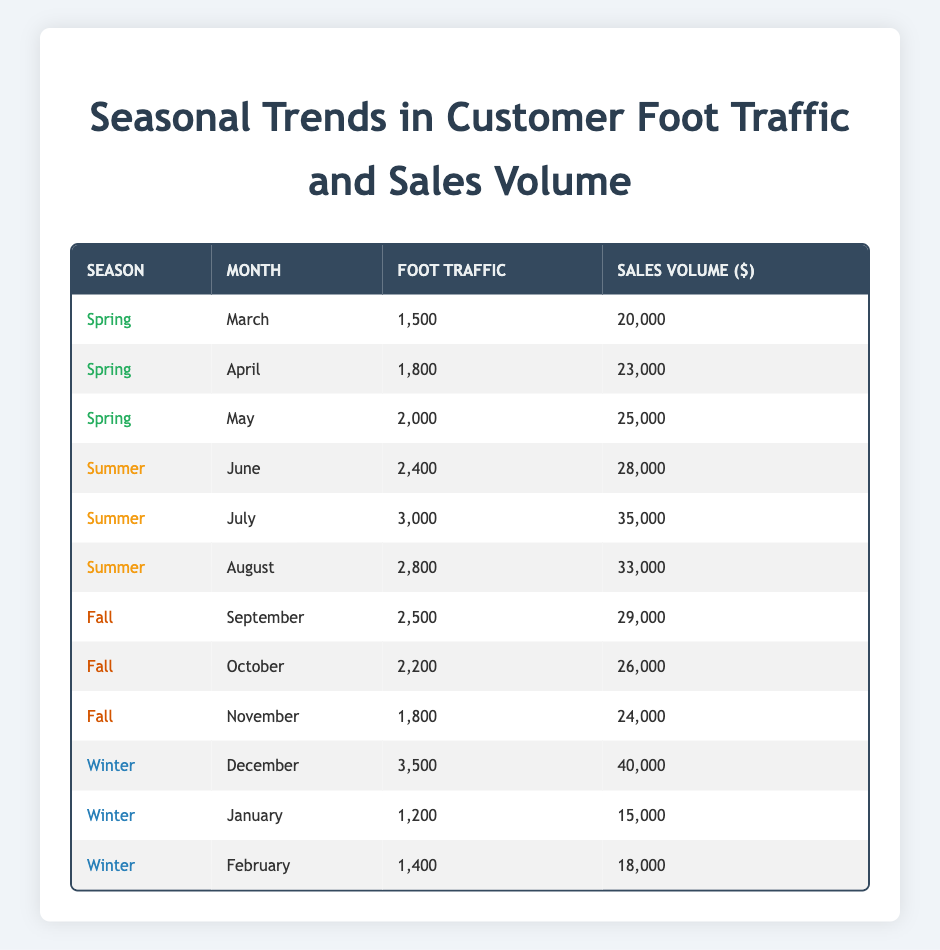What is the foot traffic in July? The table indicates that for the month of July in the summer season, the foot traffic is recorded as 3000.
Answer: 3000 What was the sales volume in December? From the table, it shows that in December during winter, the sales volume is 40000.
Answer: 40000 Which month had the highest foot traffic? To determine this, we compare the foot traffic values across all months. December has the highest foot traffic at 3500.
Answer: December What is the average sales volume for the fall season? The sales volumes for fall months (September: 29000, October: 26000, November: 24000) are summed as (29000 + 26000 + 24000 = 79000) and then divided by 3 months to find the average: 79000/3 = 26333.33.
Answer: 26333.33 Is the foot traffic in October less than in November? The foot traffic for October is 2200, while for November it is 1800. Since 2200 is greater than 1800, the statement is false.
Answer: No What season had the highest average foot traffic? First, we will calculate the average foot traffic for each season. Spring = (1500 + 1800 + 2000)/3 = 1766.67, Summer = (2400 + 3000 + 2800)/3 = 2733.33, Fall = (2500 + 2200 + 1800)/3 = 2166.67, Winter = (3500 + 1200 + 1400)/3 = 2033.33. The highest average is in Summer at 2733.33.
Answer: Summer In which month did sales exceed 30000? We check each sales volume listed in the table: July (35000), August (33000), and December (40000) are the months where sales exceeded 30000.
Answer: July, August, December What is the total foot traffic over the winter months? We will sum the foot traffic values for December, January, and February (3500 + 1200 + 1400 = 6100) to find the total.
Answer: 6100 Was there an increase in sales from March to May? In March, sales were 20000, and in May, sales increased to 25000. Since 25000 is greater than 20000, the answer is yes.
Answer: Yes 